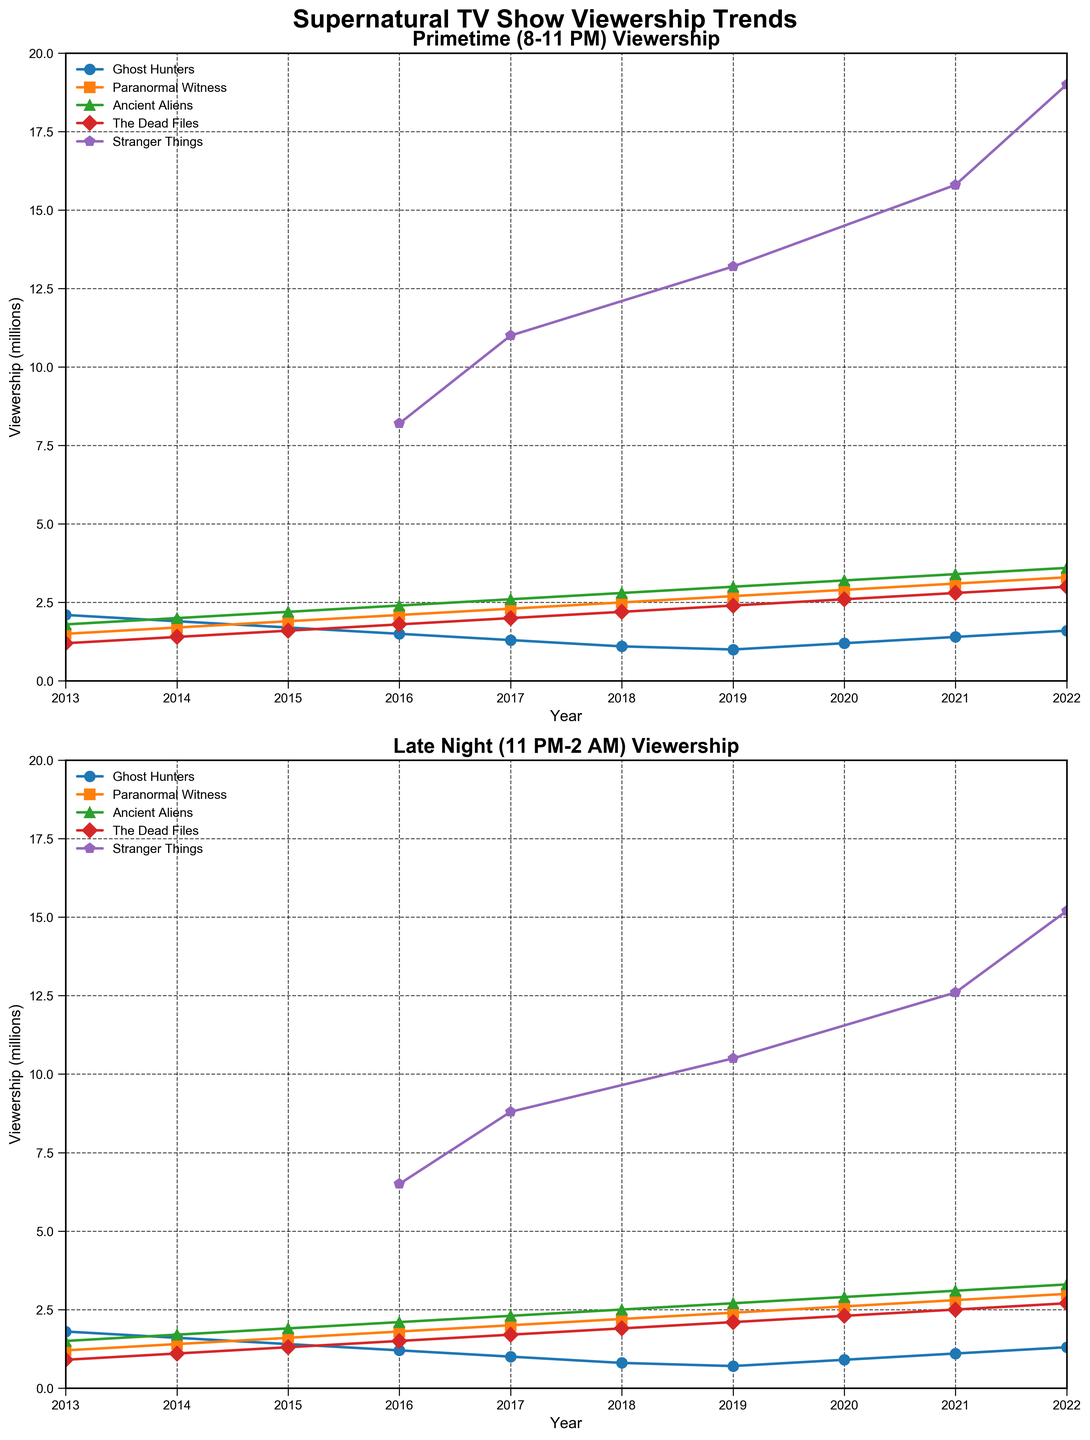what are the titles of the subplots? The titles of the subplots are prominently displayed at the top of each subplot. The first subplot is titled "Primetime (8-11 PM) Viewership," and the second subplot is titled "Late Night (11 PM-2 AM) Viewership."
Answer: Primetime (8-11 PM) Viewership, Late Night (11 PM-2 AM) Viewership How many TV shows are represented in the figure? Each subplot includes lines for five different TV shows. These TV shows are identified in the legend of each subplot. The shows are Ghost Hunters, Paranormal Witness, Ancient Aliens, The Dead Files, and Stranger Things.
Answer: 5 Which show had the highest viewership in 2017 during Primetime? By looking at the Primetime subplot for the year 2017, Stranger Things has the highest viewership. It can be identified by the highest line on the vertical axis in that year.
Answer: Stranger Things During the Late Night slot, which show had a consistent increase in viewership from 2013 to 2022? Paranormal Witness, represented by its increasing trend line on the Late Night subplot, shows a consistent rise in viewership over the years from 2013 to 2022.
Answer: Paranormal Witness Compare the viewership trends of "The Dead Files" during the Primetime and Late Night slots from 2013 to 2022. The viewership trends for The Dead Files in both time slots can be compared by examining the respective subplots. In both Primetime and Late Night slots, The Dead Files shows an upward trend, but the Late Night slot has a slower increase compared to the Primetime slot.
Answer: Both show an upward trend, but Primetime rises faster than Late Night Which year did "Ancient Aliens" surpass a viewership of 3 million during Primetime? By looking at the trend line for Ancient Aliens in the Primetime subplot, it can be observed that it surpasses the 3 million viewership mark in the year 2019.
Answer: 2019 What is the average viewership of "Ghost Hunters" in the Primetime slot from 2013 to 2022? To find this average, sum the viewership numbers for Ghost Hunters in the Primetime slot from 2013 to 2022: (2.1 + 1.9 + 1.7 + 1.5 + 1.3 + 1.1 + 1 + 1.2 + 1.4 + 1.6) = 15.8. Then divide by the number of years (10), which results in an average viewership of 1.58 million.
Answer: 1.58 Which show had a more dramatic increase in Late Night viewership from 2016 to 2017, "Stranger Things" or "Paranormal Witness"? By examining the Late Night subplot, Stranger Things increased from 6.5 to 8.8, a difference of 2.3 million. Paranormal Witness increased from 1.8 to 2, a difference of 0.2 million. Consequently, Stranger Things had a more dramatic increase.
Answer: Stranger Things Did the viewership of "Stranger Things" in the Primetime slot surpass 10 million every year it aired? By observing the trend line for Stranger Things in the Primetime subplot, it aired in 2016, 2017, 2019, 2021 and 2022. In 2016, it was 8.2 million but in subsequent years (2017, 2019, 2021, 2022), it surpassed 10 million.
Answer: No In which time slot did "Ghost Hunters" experience a larger decline in viewership from 2013 to 2018? To determine the larger decline, we compare the reductions from 2013 to 2018 in both subplots. In Primetime, it went from 2.1 to 1.1 (decline of 1.0). In Late Night, it went from 1.8 to 0.8 (decline of 1.0). Both slots experienced an equal decline in viewership.
Answer: Both had equal decline 